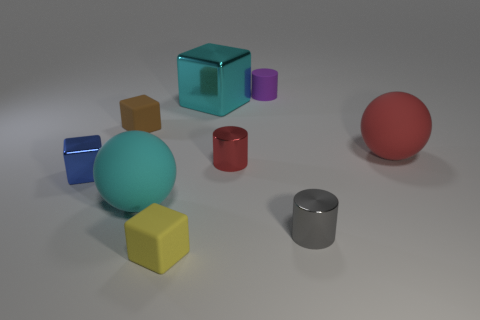There is another big object that is the same color as the big metal object; what material is it?
Your answer should be very brief. Rubber. How many matte objects are either gray objects or large cyan balls?
Provide a short and direct response. 1. The red metallic object has what size?
Make the answer very short. Small. How many things are either large cylinders or metallic things that are in front of the cyan metal block?
Provide a succinct answer. 3. What number of other things are there of the same color as the big shiny cube?
Your response must be concise. 1. There is a cyan cube; is its size the same as the matte cube that is behind the small yellow rubber cube?
Provide a succinct answer. No. There is a metal block to the right of the brown matte object; is it the same size as the purple matte cylinder?
Keep it short and to the point. No. How many other things are the same material as the large block?
Ensure brevity in your answer.  3. Are there an equal number of small gray objects left of the small gray metal cylinder and large cyan things in front of the cyan sphere?
Your answer should be compact. Yes. What is the color of the metallic block left of the large cyan object that is behind the sphere that is on the right side of the small red object?
Your answer should be compact. Blue. 